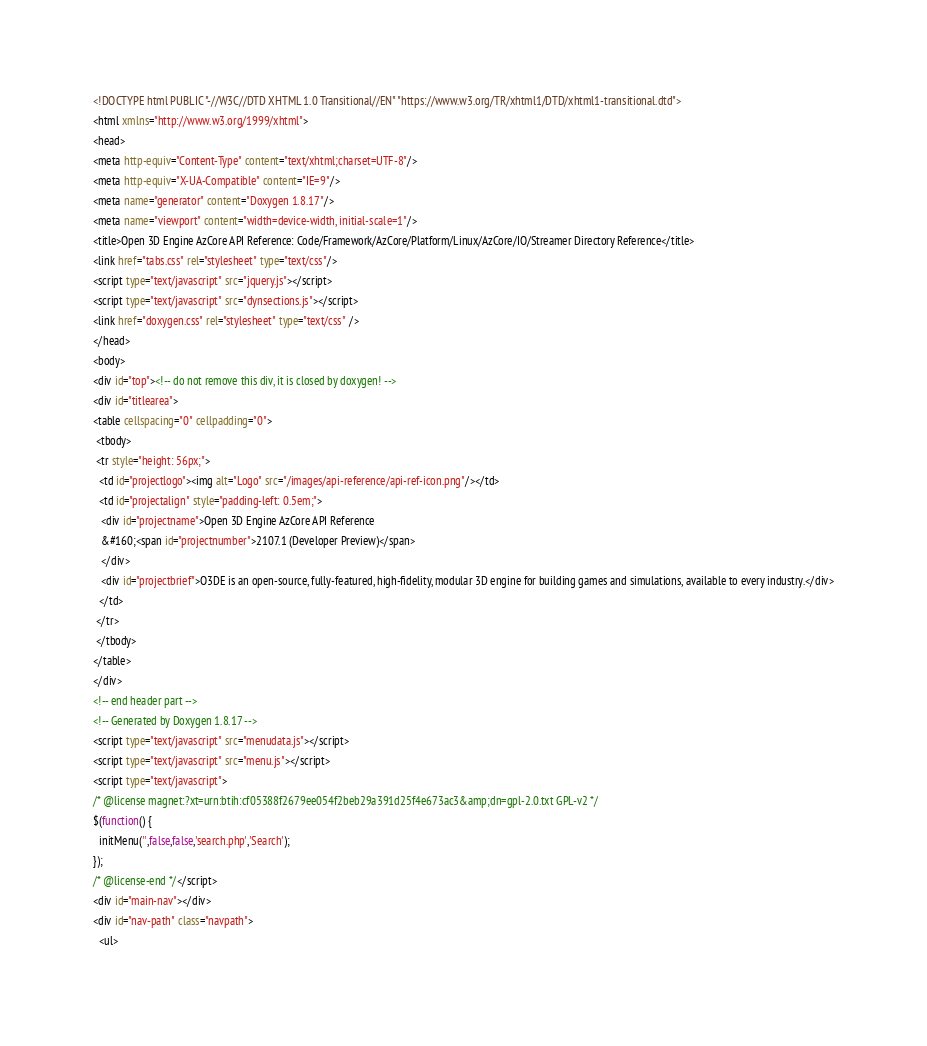Convert code to text. <code><loc_0><loc_0><loc_500><loc_500><_HTML_><!DOCTYPE html PUBLIC "-//W3C//DTD XHTML 1.0 Transitional//EN" "https://www.w3.org/TR/xhtml1/DTD/xhtml1-transitional.dtd">
<html xmlns="http://www.w3.org/1999/xhtml">
<head>
<meta http-equiv="Content-Type" content="text/xhtml;charset=UTF-8"/>
<meta http-equiv="X-UA-Compatible" content="IE=9"/>
<meta name="generator" content="Doxygen 1.8.17"/>
<meta name="viewport" content="width=device-width, initial-scale=1"/>
<title>Open 3D Engine AzCore API Reference: Code/Framework/AzCore/Platform/Linux/AzCore/IO/Streamer Directory Reference</title>
<link href="tabs.css" rel="stylesheet" type="text/css"/>
<script type="text/javascript" src="jquery.js"></script>
<script type="text/javascript" src="dynsections.js"></script>
<link href="doxygen.css" rel="stylesheet" type="text/css" />
</head>
<body>
<div id="top"><!-- do not remove this div, it is closed by doxygen! -->
<div id="titlearea">
<table cellspacing="0" cellpadding="0">
 <tbody>
 <tr style="height: 56px;">
  <td id="projectlogo"><img alt="Logo" src="/images/api-reference/api-ref-icon.png"/></td>
  <td id="projectalign" style="padding-left: 0.5em;">
   <div id="projectname">Open 3D Engine AzCore API Reference
   &#160;<span id="projectnumber">2107.1 (Developer Preview)</span>
   </div>
   <div id="projectbrief">O3DE is an open-source, fully-featured, high-fidelity, modular 3D engine for building games and simulations, available to every industry.</div>
  </td>
 </tr>
 </tbody>
</table>
</div>
<!-- end header part -->
<!-- Generated by Doxygen 1.8.17 -->
<script type="text/javascript" src="menudata.js"></script>
<script type="text/javascript" src="menu.js"></script>
<script type="text/javascript">
/* @license magnet:?xt=urn:btih:cf05388f2679ee054f2beb29a391d25f4e673ac3&amp;dn=gpl-2.0.txt GPL-v2 */
$(function() {
  initMenu('',false,false,'search.php','Search');
});
/* @license-end */</script>
<div id="main-nav"></div>
<div id="nav-path" class="navpath">
  <ul></code> 